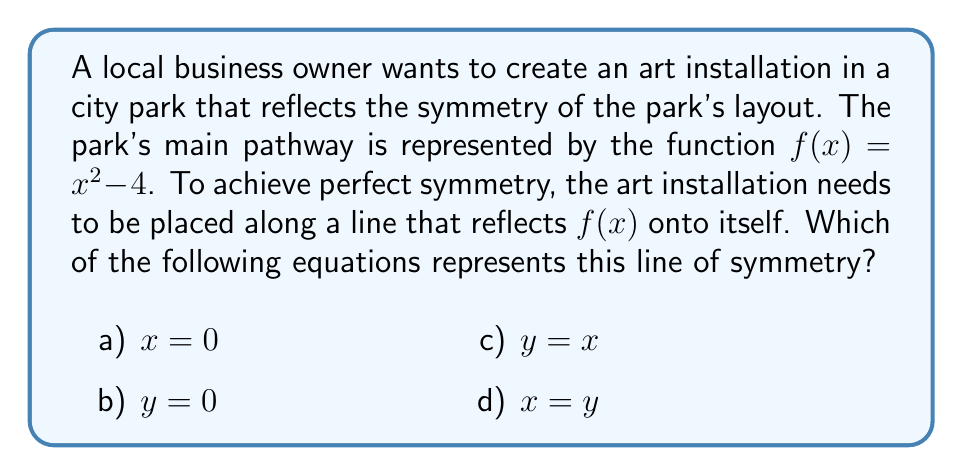Can you solve this math problem? To determine the line of symmetry for the function $f(x) = x^2 - 4$, we need to follow these steps:

1) First, recall that parabolas of the form $f(x) = ax^2 + bx + c$ are symmetric about a vertical line passing through the vertex.

2) To find the vertex, we can use the formula $x = -\frac{b}{2a}$. In this case, $a=1$ and $b=0$, so:

   $x = -\frac{0}{2(1)} = 0$

3) This means the vertex is located at $x = 0$.

4) The line of symmetry for a parabola is always a vertical line passing through the vertex.

5) Therefore, the equation of the line of symmetry is $x = 0$.

6) Checking the given options, we can see that $x = 0$ is option a).

This line of symmetry means that for any point $(x, y)$ on the parabola, there is a corresponding point $(-x, y)$ also on the parabola. The art installation placed along this line would create a perfectly symmetrical design reflecting the park's layout.
Answer: a) $x = 0$ 